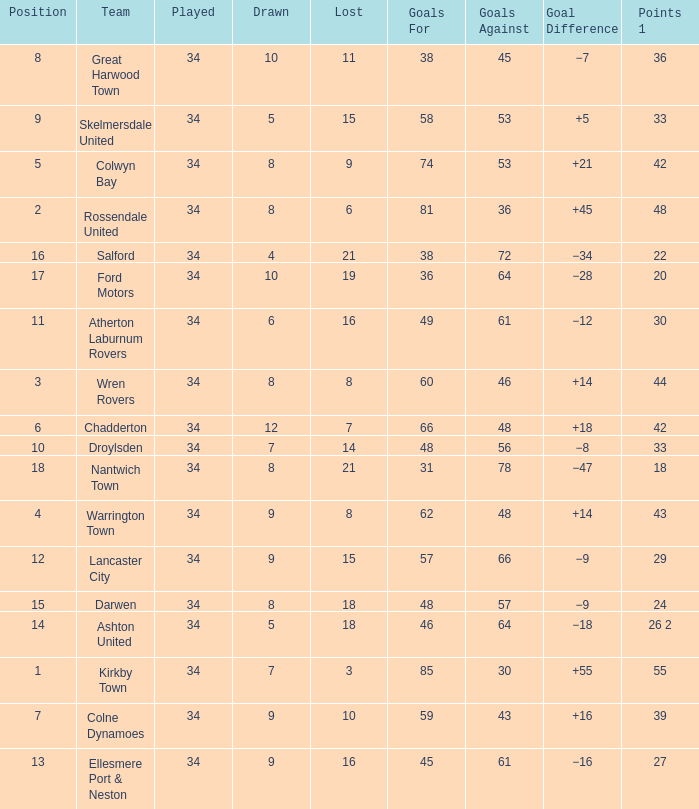What is the total number of goals for when the drawn is less than 7, less than 21 games have been lost, and there are 1 of 33 points? 1.0. 